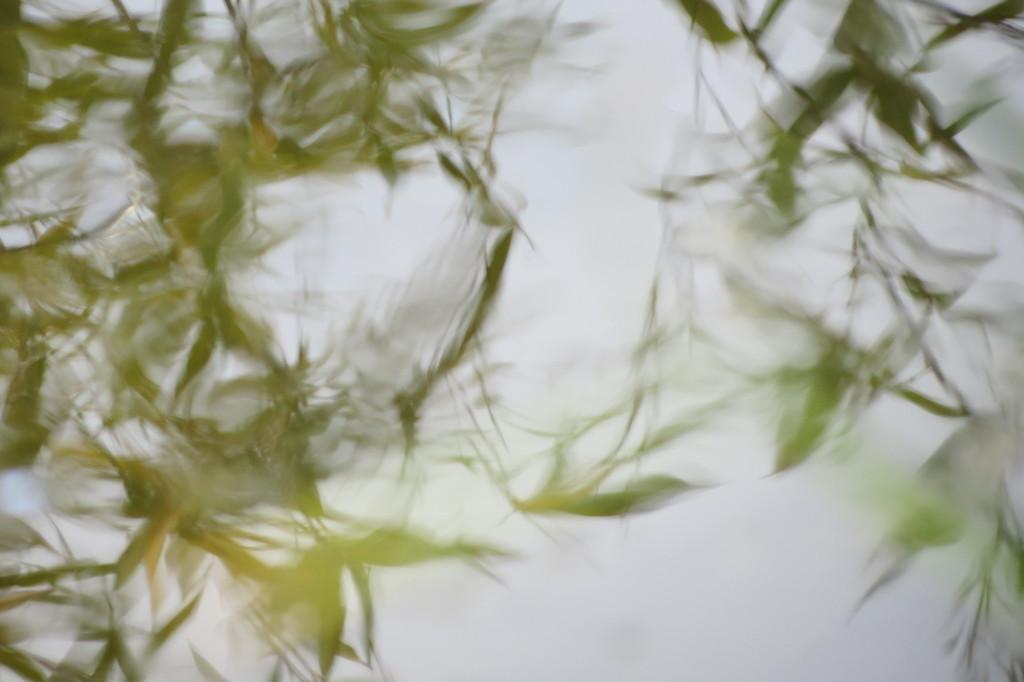What is the primary element visible in the image? There are many leaves in the image. Can you describe the leaves in the image? The leaves are likely from a tree or plant, and they may be of different shapes, sizes, and colors. What might be the source of these leaves? The leaves could be from a tree, plant, or even fallen from a higher location. How many credits are required to purchase the leaves in the image? There is no indication of a transaction or currency in the image, so it is not possible to determine the number of credits required to purchase the leaves. 